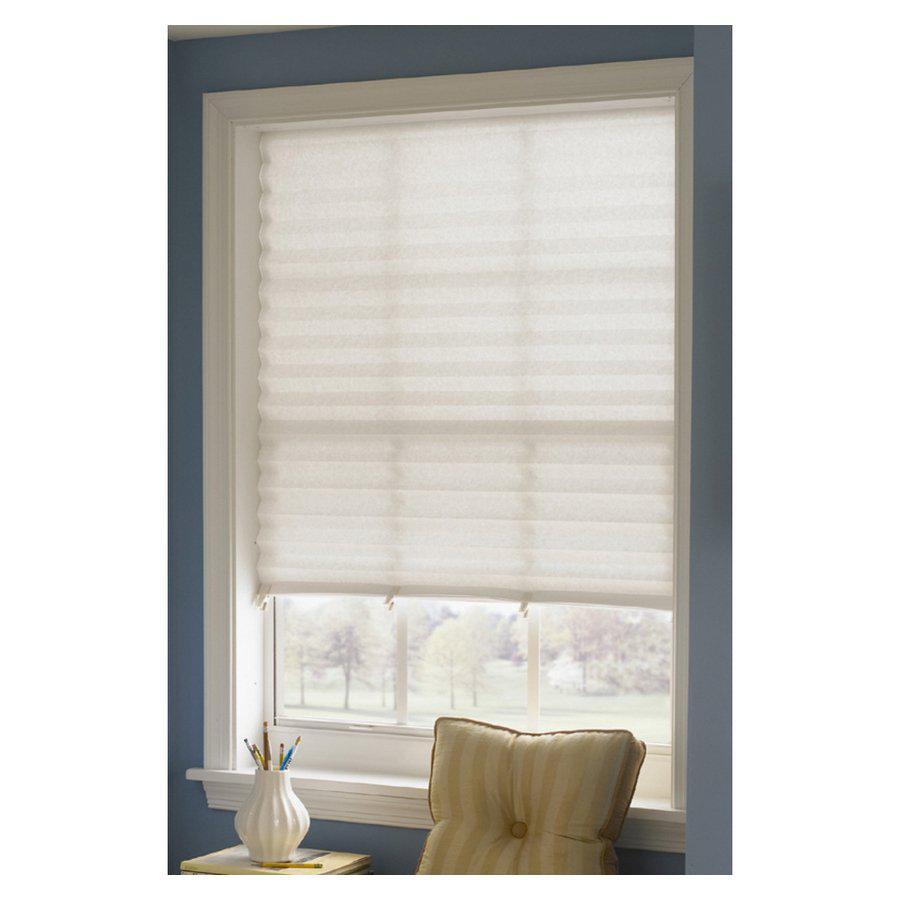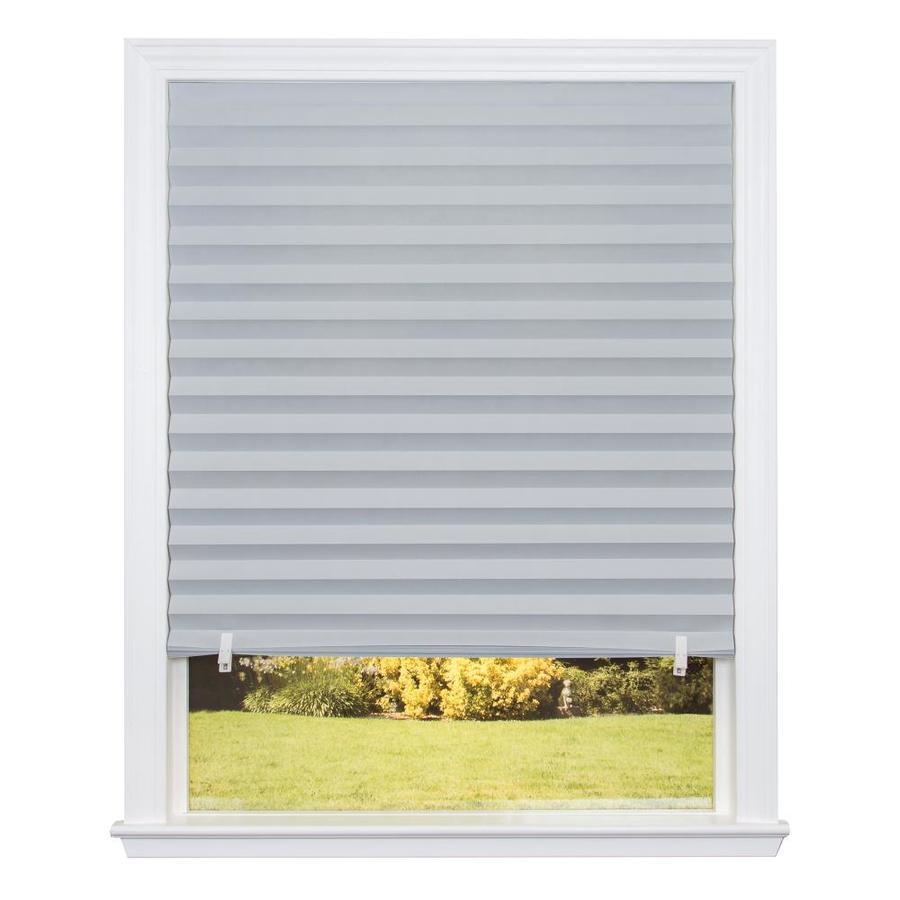The first image is the image on the left, the second image is the image on the right. For the images shown, is this caption "There are exactly three shades." true? Answer yes or no. No. The first image is the image on the left, the second image is the image on the right. Considering the images on both sides, is "There are three blinds." valid? Answer yes or no. No. 